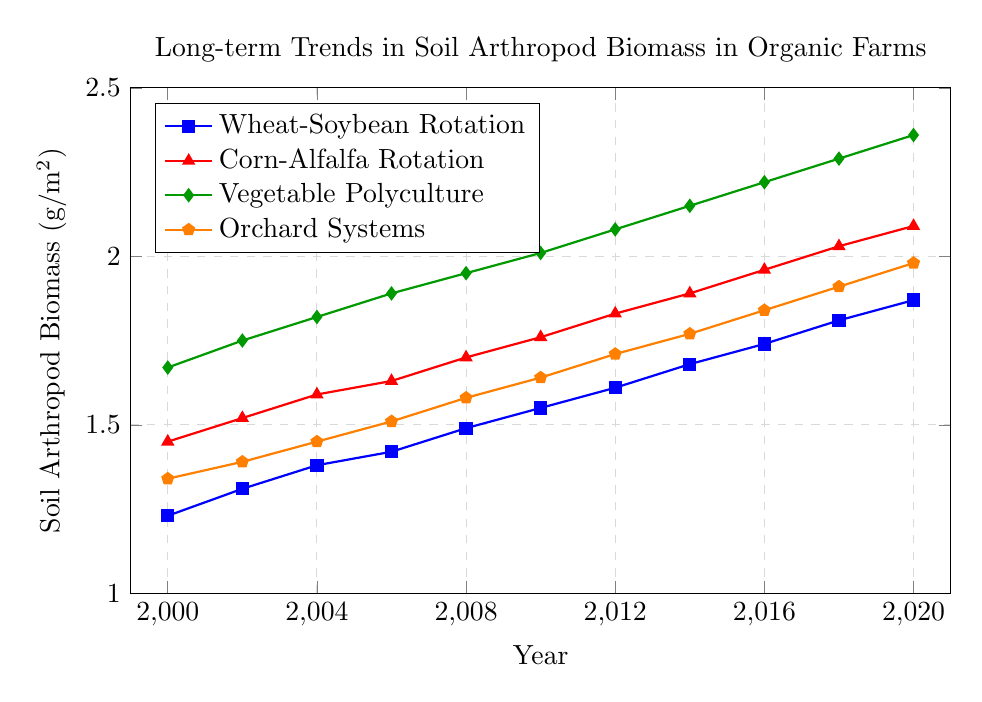What is the trend of soil arthropod biomass in the "Vegetable Polyculture" system over the years? The trend can be observed by following the green line with diamond markers representing "Vegetable Polyculture" across the years. From 2000 to 2020, the soil arthropod biomass in this system shows a consistent increasing trend. Starting at 1.67 g/m² in 2000, it reaches 2.36 g/m² in 2020.
Answer: Increasing Which crop rotation system had the highest soil arthropod biomass in 2020? To find which system had the highest biomass in 2020, we look at the values for each system in that year. The "Vegetable Polyculture" system had the highest value at 2.36 g/m².
Answer: Vegetable Polyculture How does the soil arthropod biomass in the "Corn-Alfalfa Rotation" system in 2010 compare to that in the "Orchard Systems" in the same year? The values for 2010 show 1.76 g/m² for "Corn-Alfalfa Rotation" and 1.64 g/m² for "Orchard Systems". Therefore, "Corn-Alfalfa Rotation" had a higher biomass in 2010.
Answer: Corn-Alfalfa Rotation is higher What is the difference in soil arthropod biomass between "Wheat-Soybean Rotation" and "Orchard Systems" in 2016? For 2016, "Wheat-Soybean Rotation" has a value of 1.74 g/m² and "Orchard Systems" has a value of 1.84 g/m². The difference is 1.84 - 1.74 = 0.1 g/m², with "Orchard Systems" being higher.
Answer: 0.1 g/m² Which crop rotation system shows the most rapid increase in biomass between 2000 and 2020? The system showing the most rapid increase can be determined by looking at the difference in biomass values between 2000 and 2020. "Vegetable Polyculture" increased from 1.67 g/m² to 2.36 g/m², an increase of 0.69 g/m². This is the largest increase compared to other systems.
Answer: Vegetable Polyculture What is the average soil arthropod biomass for the "Wheat-Soybean Rotation" system from 2000 to 2020? Summing all the values for "Wheat-Soybean Rotation" from 2000 to 2020 gives 1.23 + 1.31 + 1.38 + 1.42 + 1.49 + 1.55 + 1.61 + 1.68 + 1.74 + 1.81 + 1.87 = 17.09. There are 11 data points, so the average is 17.09 / 11 ≈ 1.55 g/m².
Answer: 1.55 g/m² In which year did the "Orchard Systems" first surpass a soil arthropod biomass of 1.5 g/m²? The biomass for "Orchard Systems" crosses 1.5 g/m² between 2006 and 2008, reaching 1.58 g/m² in 2008. Hence, the year is 2008.
Answer: 2008 How much did the soil arthropod biomass increase in the "Corn-Alfalfa Rotation" system from 2000 to 2020? The initial biomass in 2000 was 1.45 g/m², and in 2020 it was 2.09 g/m². The increase is 2.09 - 1.45 = 0.64 g/m².
Answer: 0.64 g/m² Rank the crop rotation systems in terms of their soil arthropod biomass in 2012 from highest to lowest. The biomass values in 2012 are: "Vegetable Polyculture" 2.08 g/m², "Corn-Alfalfa Rotation" 1.83 g/m², "Orchard Systems" 1.71 g/m², and "Wheat-Soybean Rotation" 1.61 g/m². Ranking from highest to lowest: Vegetable Polyculture > Corn-Alfalfa Rotation > Orchard Systems > Wheat-Soybean Rotation.
Answer: Vegetable Polyculture > Corn-Alfalfa Rotation > Orchard Systems > Wheat-Soybean Rotation 